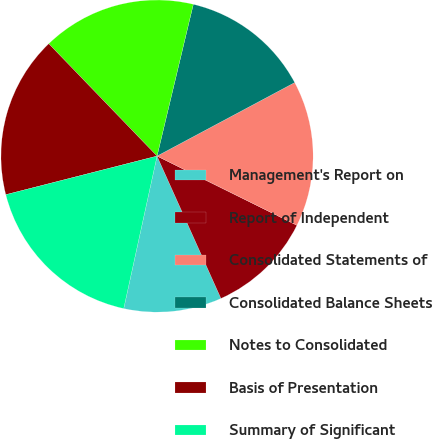Convert chart to OTSL. <chart><loc_0><loc_0><loc_500><loc_500><pie_chart><fcel>Management's Report on<fcel>Report of Independent<fcel>Consolidated Statements of<fcel>Consolidated Balance Sheets<fcel>Notes to Consolidated<fcel>Basis of Presentation<fcel>Summary of Significant<nl><fcel>10.14%<fcel>10.97%<fcel>15.12%<fcel>13.46%<fcel>15.94%<fcel>16.77%<fcel>17.6%<nl></chart> 